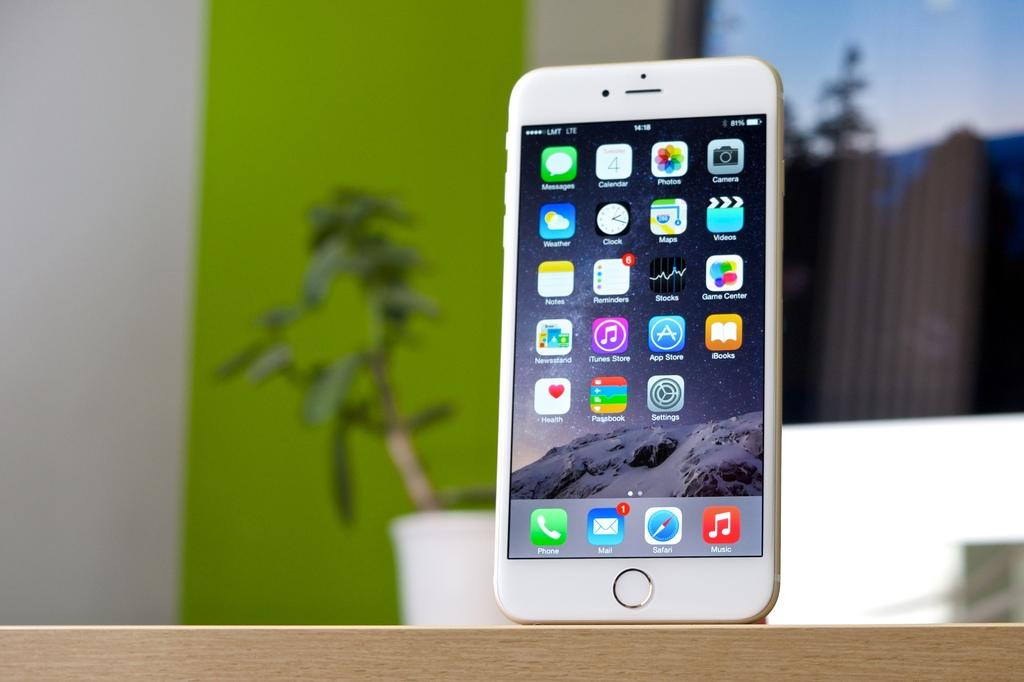<image>
Give a short and clear explanation of the subsequent image. A cell phone display shows that there is one unread email message. 